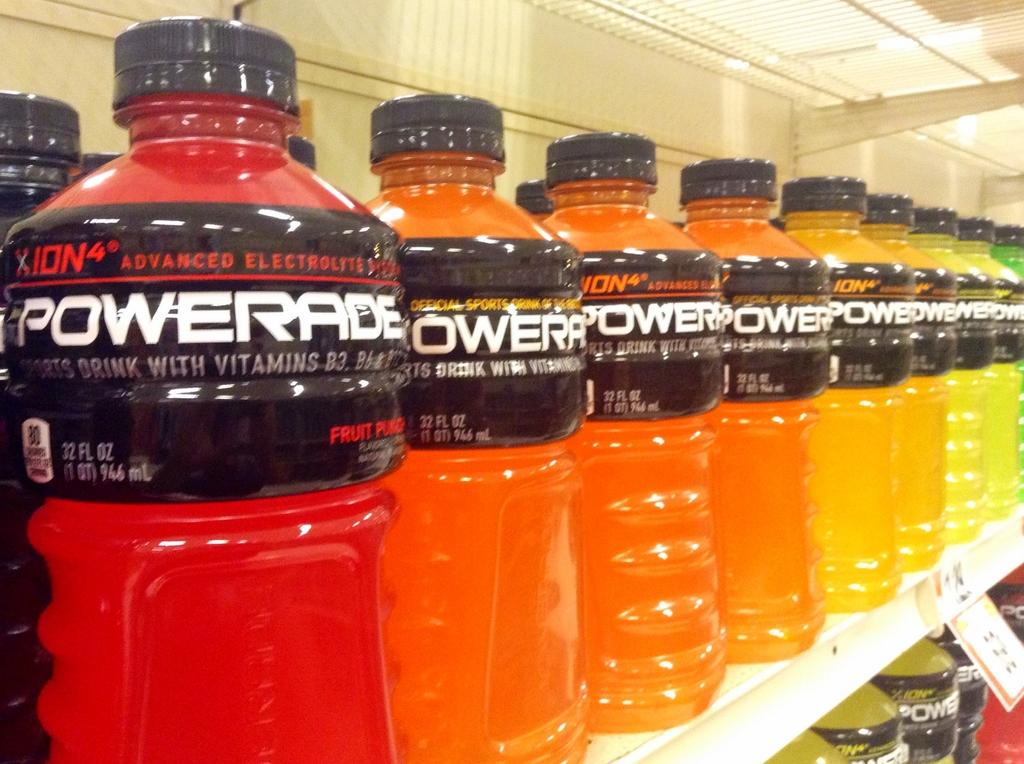Provide a one-sentence caption for the provided image. A row of bottles of Powerade on the shelf of a grocery store. 